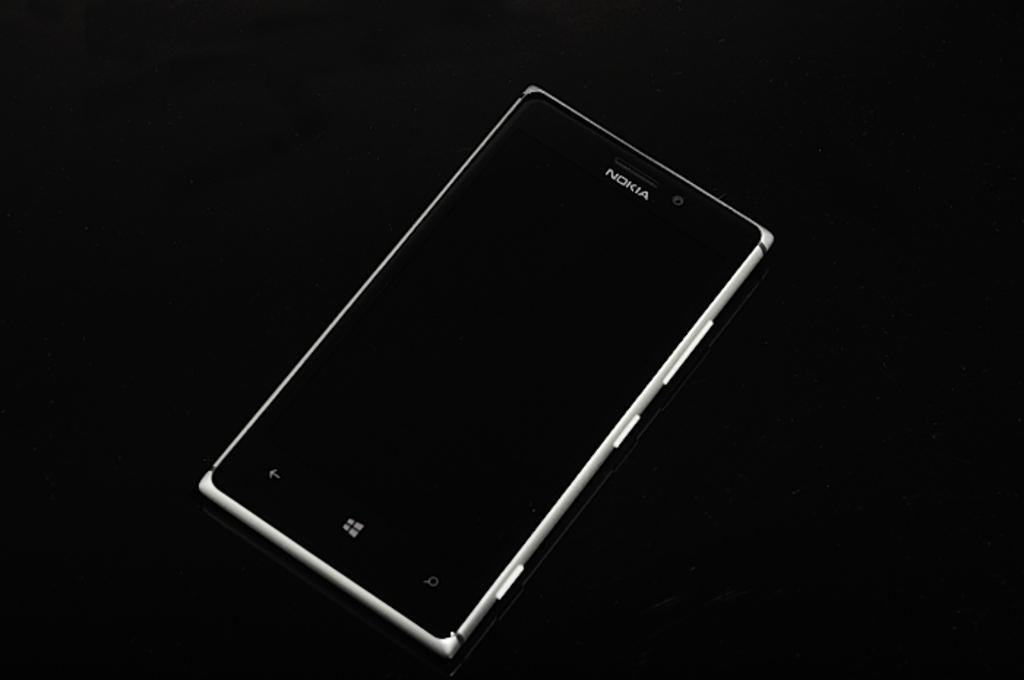Provide a one-sentence caption for the provided image. A Nokia cell phone is resting a black background. 